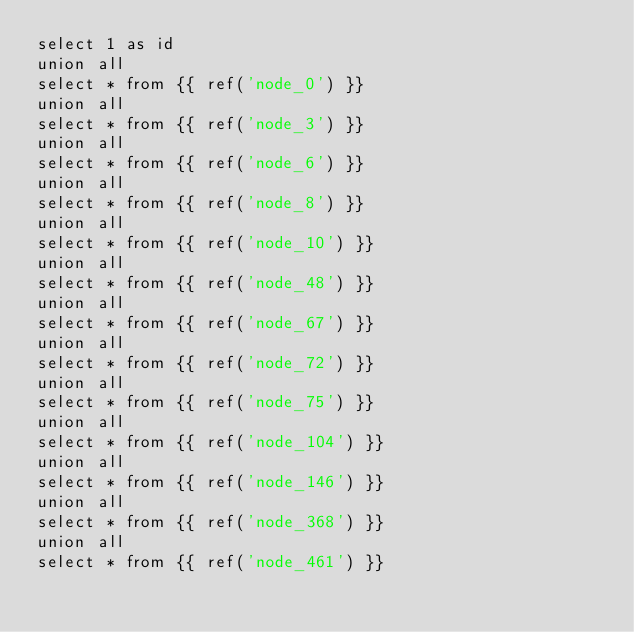<code> <loc_0><loc_0><loc_500><loc_500><_SQL_>select 1 as id
union all
select * from {{ ref('node_0') }}
union all
select * from {{ ref('node_3') }}
union all
select * from {{ ref('node_6') }}
union all
select * from {{ ref('node_8') }}
union all
select * from {{ ref('node_10') }}
union all
select * from {{ ref('node_48') }}
union all
select * from {{ ref('node_67') }}
union all
select * from {{ ref('node_72') }}
union all
select * from {{ ref('node_75') }}
union all
select * from {{ ref('node_104') }}
union all
select * from {{ ref('node_146') }}
union all
select * from {{ ref('node_368') }}
union all
select * from {{ ref('node_461') }}
</code> 